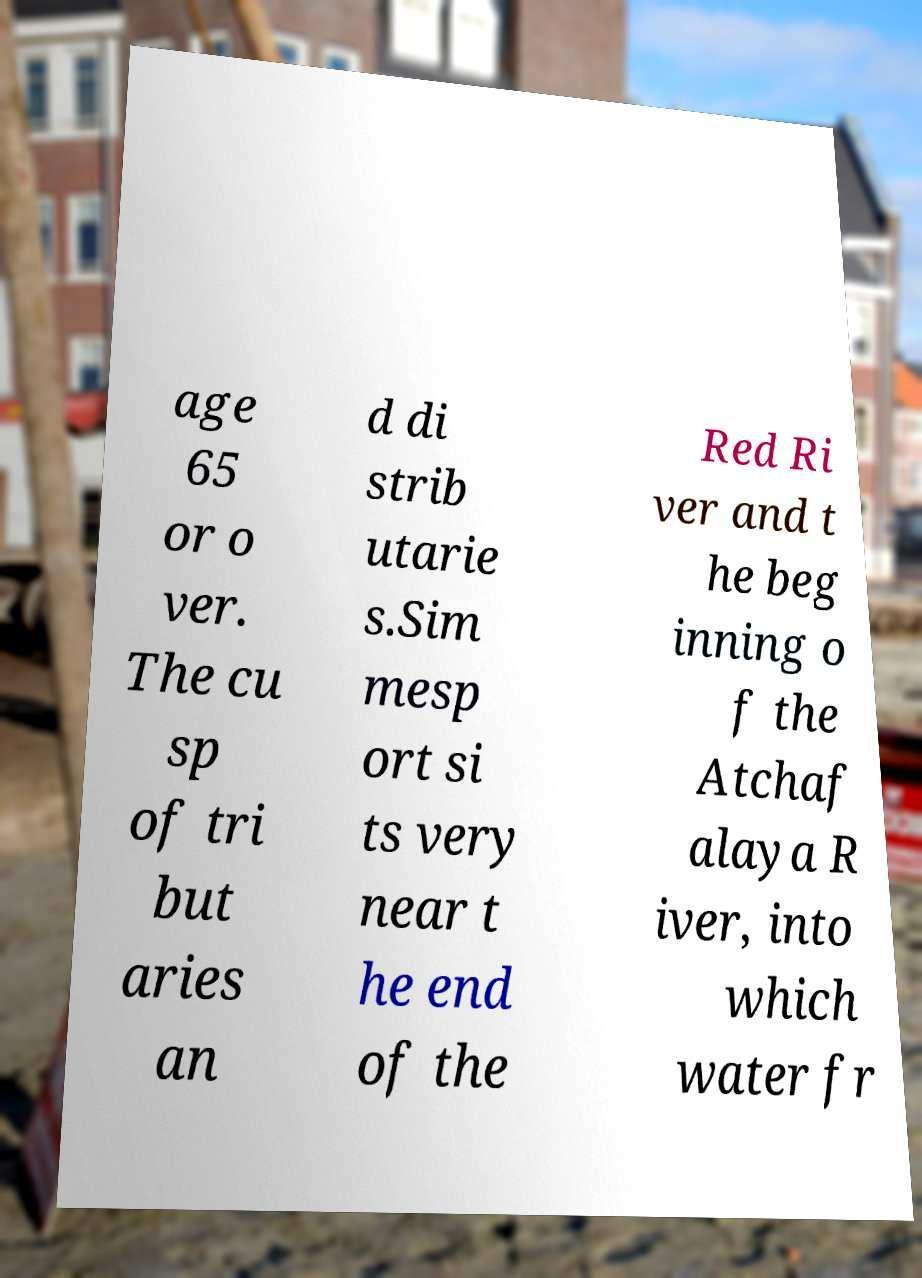Can you accurately transcribe the text from the provided image for me? age 65 or o ver. The cu sp of tri but aries an d di strib utarie s.Sim mesp ort si ts very near t he end of the Red Ri ver and t he beg inning o f the Atchaf alaya R iver, into which water fr 